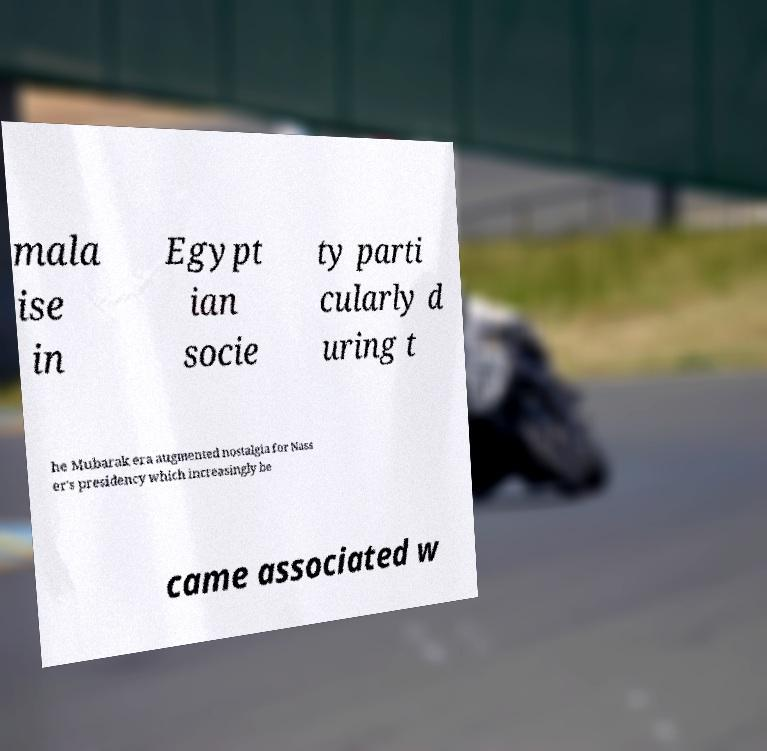I need the written content from this picture converted into text. Can you do that? mala ise in Egypt ian socie ty parti cularly d uring t he Mubarak era augmented nostalgia for Nass er's presidency which increasingly be came associated w 